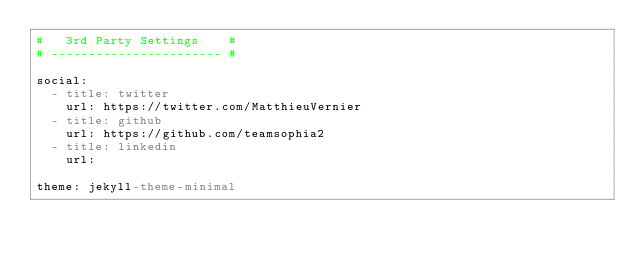Convert code to text. <code><loc_0><loc_0><loc_500><loc_500><_YAML_>#   3rd Party Settings    #
# ----------------------- #

social:
  - title: twitter
    url: https://twitter.com/MatthieuVernier
  - title: github
    url: https://github.com/teamsophia2
  - title: linkedin
    url: 

theme: jekyll-theme-minimal
</code> 